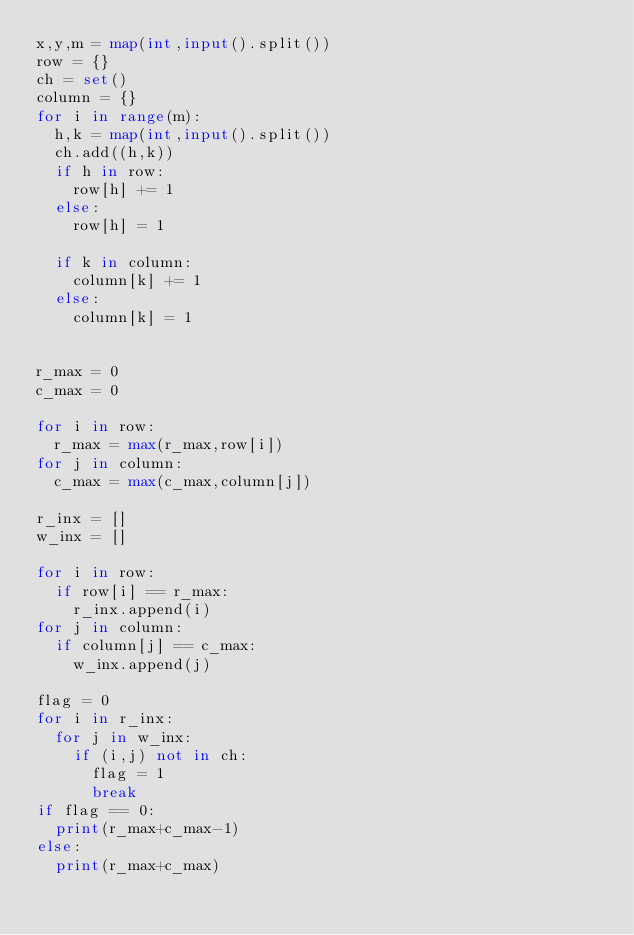Convert code to text. <code><loc_0><loc_0><loc_500><loc_500><_Python_>x,y,m = map(int,input().split())
row = {}
ch = set()
column = {}
for i in range(m):
	h,k = map(int,input().split())
	ch.add((h,k))
	if h in row:
		row[h] += 1
	else:
		row[h] = 1

	if k in column:
		column[k] += 1
	else:
		column[k] = 1


r_max = 0
c_max = 0

for i in row:
	r_max = max(r_max,row[i])
for j in column:
	c_max = max(c_max,column[j])

r_inx = []
w_inx = []

for i in row:
	if row[i] == r_max:
		r_inx.append(i)
for j in column:
	if column[j] == c_max:
		w_inx.append(j)

flag = 0
for i in r_inx:
	for j in w_inx:
		if (i,j) not in ch:
			flag = 1
			break
if flag == 0:
	print(r_max+c_max-1)
else:
	print(r_max+c_max)</code> 